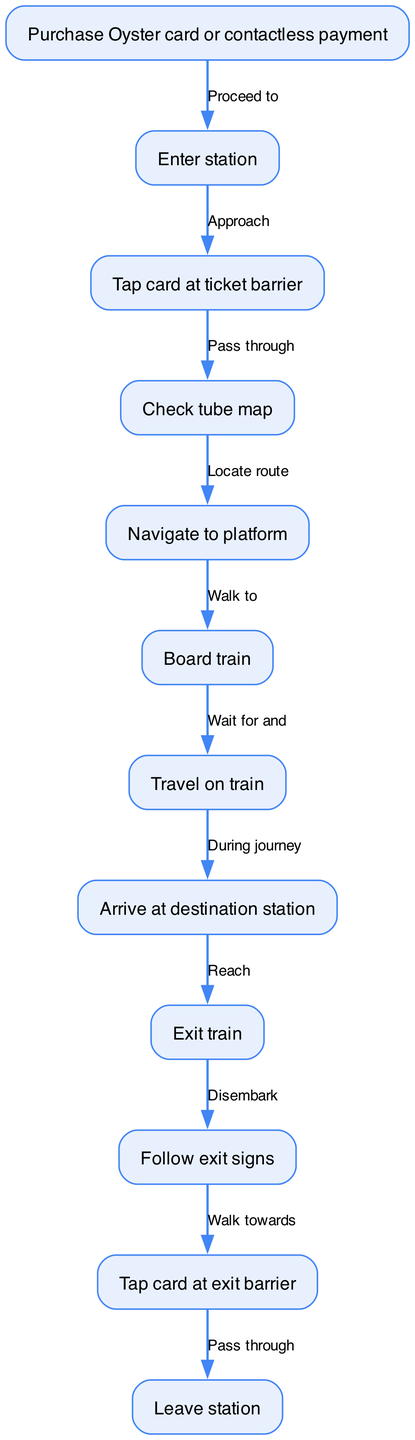What is the first step in the journey? The first step in the journey is "Purchase Oyster card or contactless payment." This information can be found at the top of the flow chart, where the journey begins.
Answer: Purchase Oyster card or contactless payment How many nodes are in the diagram? The diagram contains a total of 12 nodes, which can be counted by reviewing the list of journey steps provided in the nodes section of the flow chart.
Answer: 12 What do you do after entering the station? After entering the station, the next action is to "Tap card at ticket barrier." This can be seen as the direct continuation in the flow from the "Enter station" node.
Answer: Tap card at ticket barrier What is the relationship between "Board train" and "Travel on train"? The relationship is a sequential flow where "Board train" leads directly to "Travel on train." This means after boarding the train, the passenger then travels on it.
Answer: Proceed to What is the last action in the journey? The last action in the journey is "Leave station." This is the final step before completing the journey after passing through the exit barrier.
Answer: Leave station What happens immediately after "Arrive at destination station"? Immediately after arriving at the destination station, the passenger's next action is to "Exit train." This shows the flow from arriving at the station to departing from the train.
Answer: Exit train How many edges connect the nodes in the diagram? There are 11 edges that connect the 12 nodes. This can be inferred by noting that each connection between two nodes represents an edge, and as the flow begins from the first node to the last, the total is one less than the number of nodes.
Answer: 11 What action follows "Navigate to platform"? The action that follows "Navigate to platform" is "Board train." This continues the transportation process leading towards the end of the journey.
Answer: Board train What does a passenger do at the exit barrier? At the exit barrier, the passenger needs to "Tap card at exit barrier." This is part of the final movement out of the station.
Answer: Tap card at exit barrier 